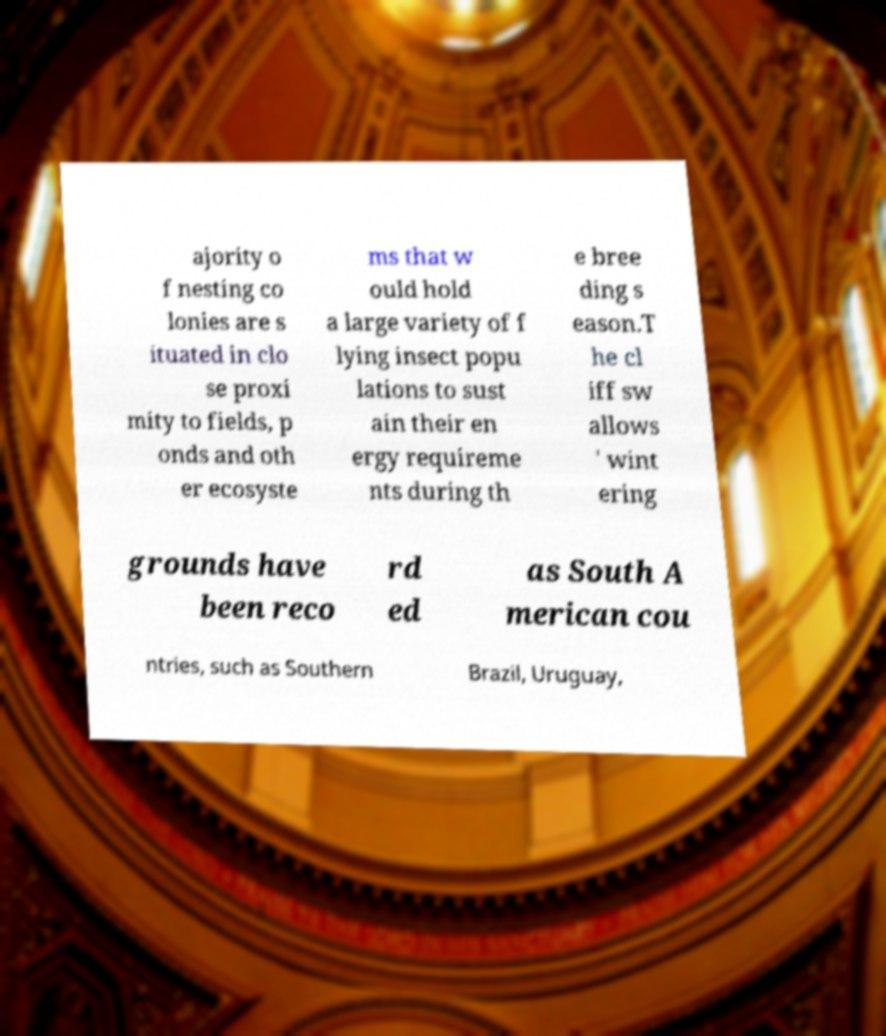There's text embedded in this image that I need extracted. Can you transcribe it verbatim? ajority o f nesting co lonies are s ituated in clo se proxi mity to fields, p onds and oth er ecosyste ms that w ould hold a large variety of f lying insect popu lations to sust ain their en ergy requireme nts during th e bree ding s eason.T he cl iff sw allows ' wint ering grounds have been reco rd ed as South A merican cou ntries, such as Southern Brazil, Uruguay, 